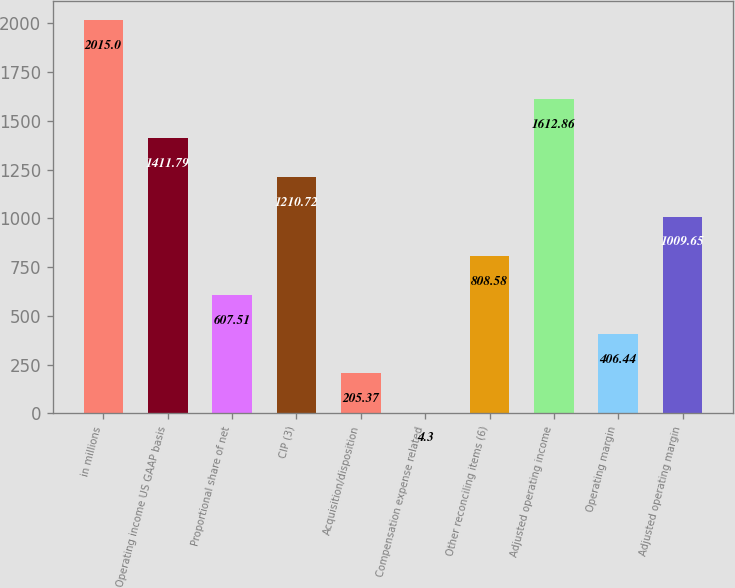<chart> <loc_0><loc_0><loc_500><loc_500><bar_chart><fcel>in millions<fcel>Operating income US GAAP basis<fcel>Proportional share of net<fcel>CIP (3)<fcel>Acquisition/disposition<fcel>Compensation expense related<fcel>Other reconciling items (6)<fcel>Adjusted operating income<fcel>Operating margin<fcel>Adjusted operating margin<nl><fcel>2015<fcel>1411.79<fcel>607.51<fcel>1210.72<fcel>205.37<fcel>4.3<fcel>808.58<fcel>1612.86<fcel>406.44<fcel>1009.65<nl></chart> 